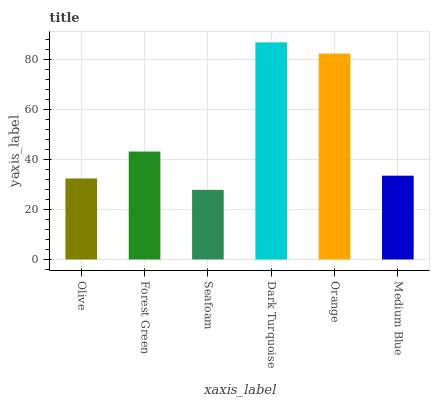Is Seafoam the minimum?
Answer yes or no. Yes. Is Dark Turquoise the maximum?
Answer yes or no. Yes. Is Forest Green the minimum?
Answer yes or no. No. Is Forest Green the maximum?
Answer yes or no. No. Is Forest Green greater than Olive?
Answer yes or no. Yes. Is Olive less than Forest Green?
Answer yes or no. Yes. Is Olive greater than Forest Green?
Answer yes or no. No. Is Forest Green less than Olive?
Answer yes or no. No. Is Forest Green the high median?
Answer yes or no. Yes. Is Medium Blue the low median?
Answer yes or no. Yes. Is Medium Blue the high median?
Answer yes or no. No. Is Olive the low median?
Answer yes or no. No. 